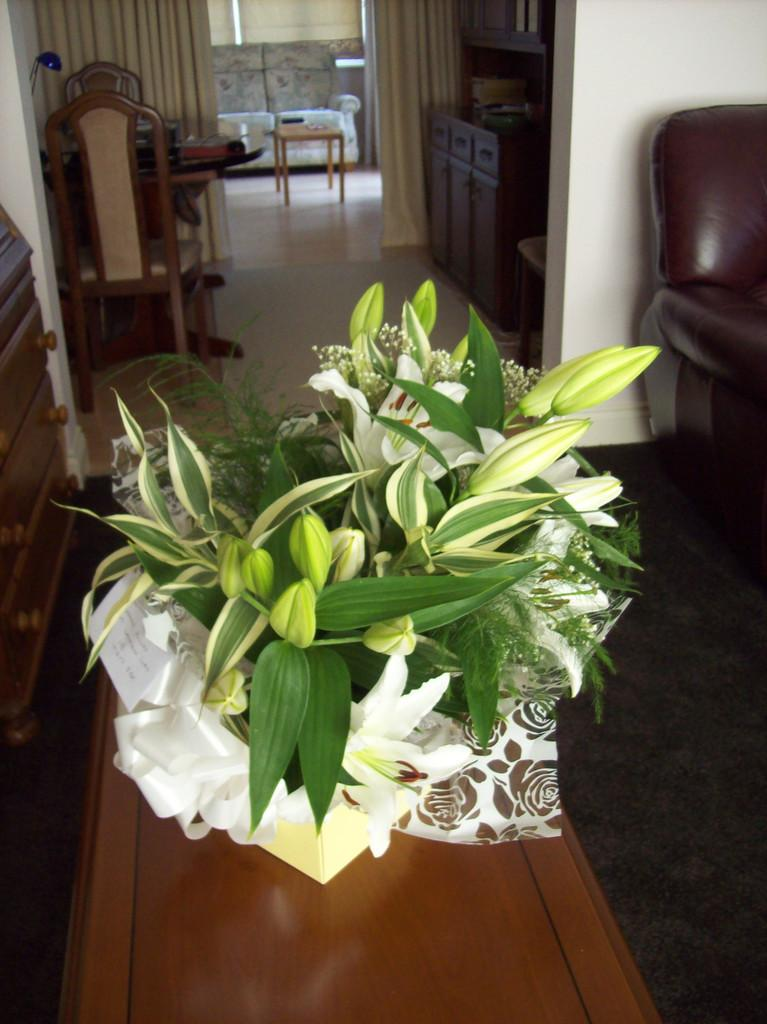Where was the image taken? The image was taken in a home. What piece of furniture is present in the image? There is a table in the image. What is placed on the table? There is a flower pot on the table. What is located behind the flower pot? There are chairs and additional tables behind the flower pot. What can be seen on the walls in the image? There is a wall visible in the image. What type of oil is being used to cook the food in the image? There is no food or cooking activity visible in the image, so it is not possible to determine if any oil is being used. How many sticks are being used to support the structure in the image? There is no structure or sticks present in the image. 